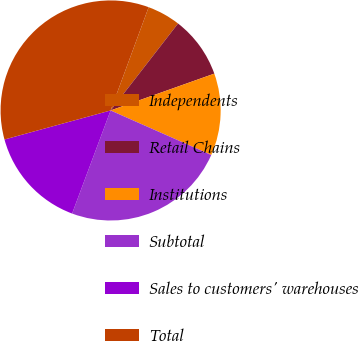<chart> <loc_0><loc_0><loc_500><loc_500><pie_chart><fcel>Independents<fcel>Retail Chains<fcel>Institutions<fcel>Subtotal<fcel>Sales to customers' warehouses<fcel>Total<nl><fcel>4.88%<fcel>9.07%<fcel>12.06%<fcel>24.06%<fcel>15.06%<fcel>34.87%<nl></chart> 